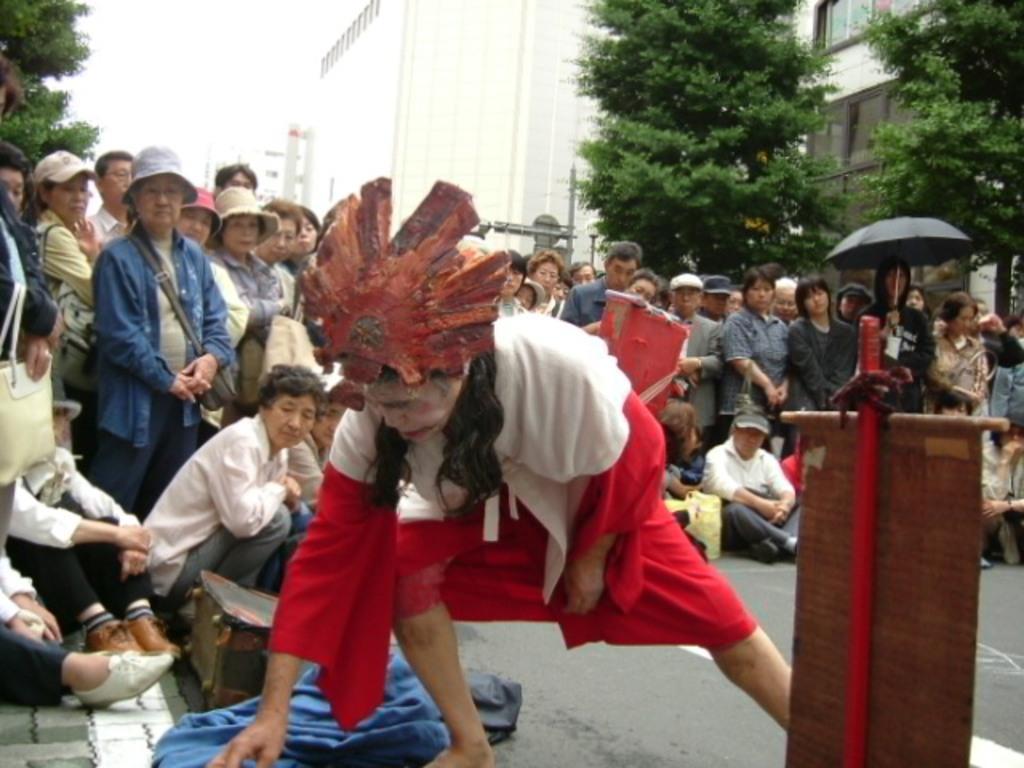In one or two sentences, can you explain what this image depicts? In front of the image there is a person bent, behind him there are a few other people standing and sitting on the road and there are some objects on the road, beside the person there is a wooden object, in the background of the image there are trees and buildings. 